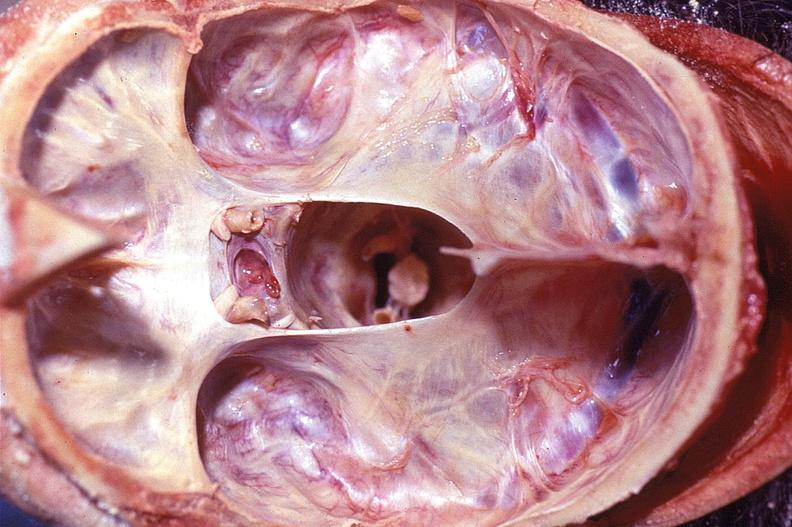does this section showing liver with tumor mass in hilar area tumor show calvarium, sella turcica pituitary gland, normal?
Answer the question using a single word or phrase. No 